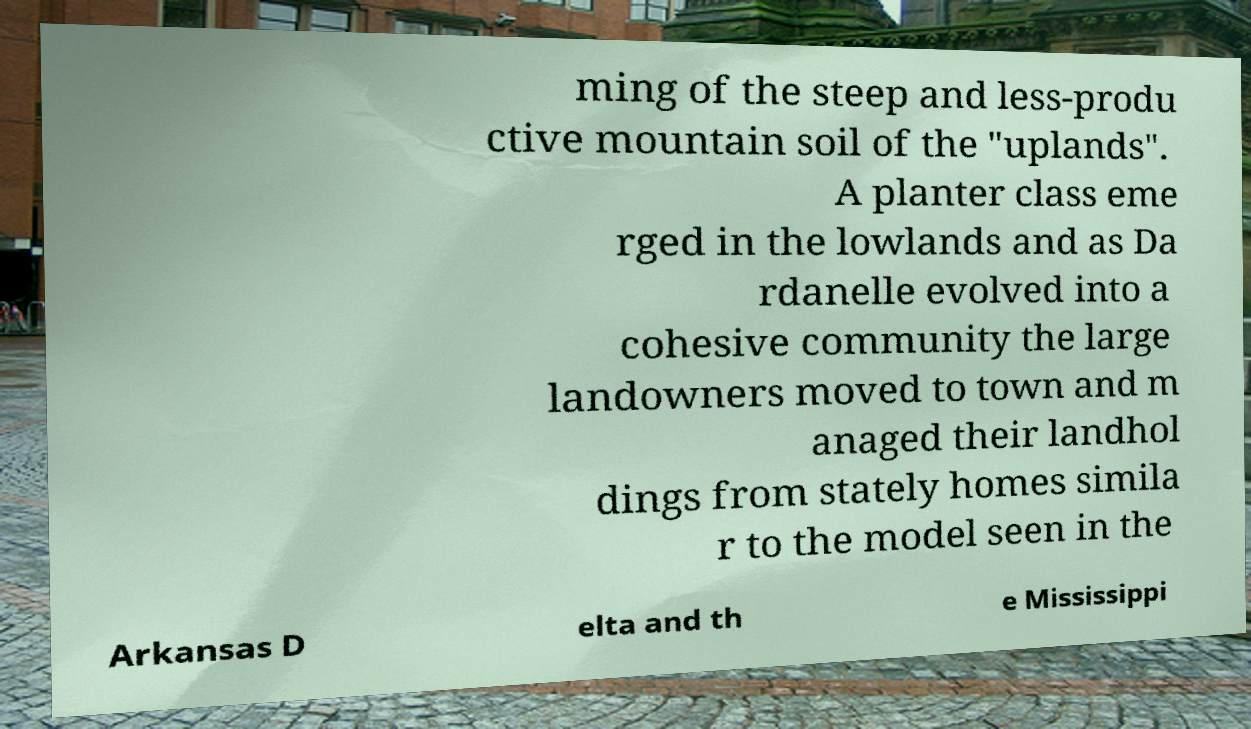Please read and relay the text visible in this image. What does it say? ming of the steep and less-produ ctive mountain soil of the "uplands". A planter class eme rged in the lowlands and as Da rdanelle evolved into a cohesive community the large landowners moved to town and m anaged their landhol dings from stately homes simila r to the model seen in the Arkansas D elta and th e Mississippi 